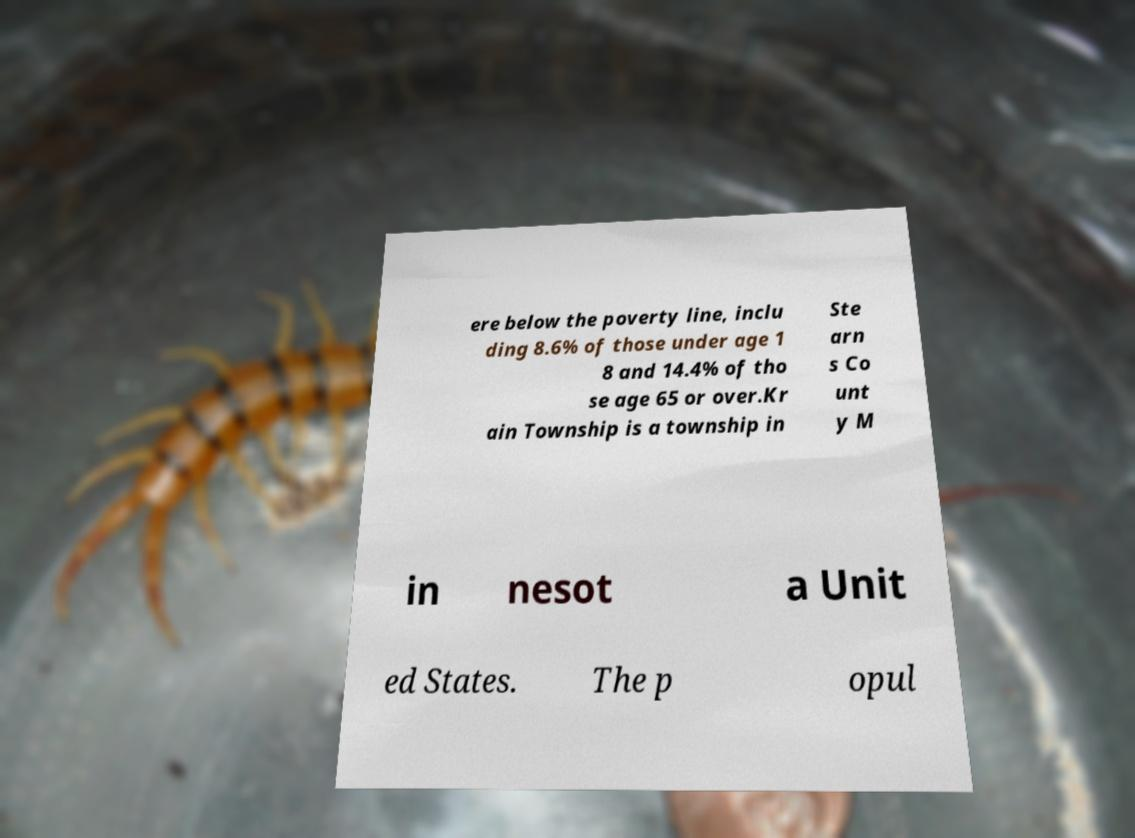Can you accurately transcribe the text from the provided image for me? ere below the poverty line, inclu ding 8.6% of those under age 1 8 and 14.4% of tho se age 65 or over.Kr ain Township is a township in Ste arn s Co unt y M in nesot a Unit ed States. The p opul 